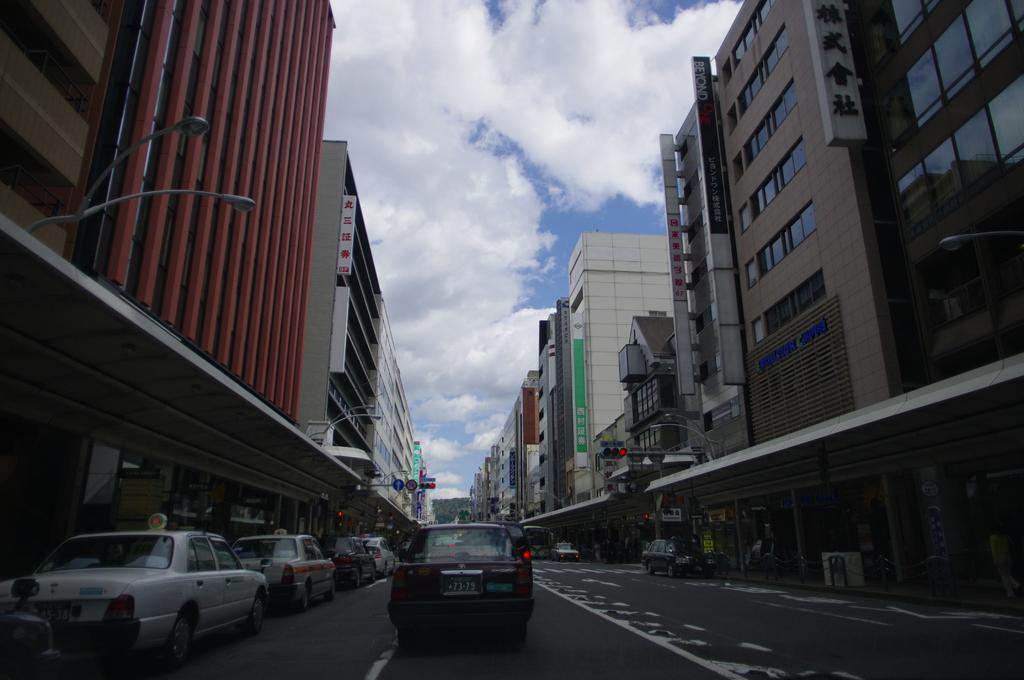What type of vehicles can be seen on the road in the image? There are cars on the road in the image. What structures are visible in the image? There are buildings in the image. What objects are present alongside the road in the image? There are poles in the image. What is visible at the top of the image? The sky is visible at the top of the image. Can you tell me how many people are involved in the fight in the image? There is no fight present in the image; it features cars on the road, buildings, poles, and the sky. What type of holiday is being celebrated in the image? There is no holiday being celebrated in the image; it simply shows a scene with cars, buildings, poles, and the sky. 